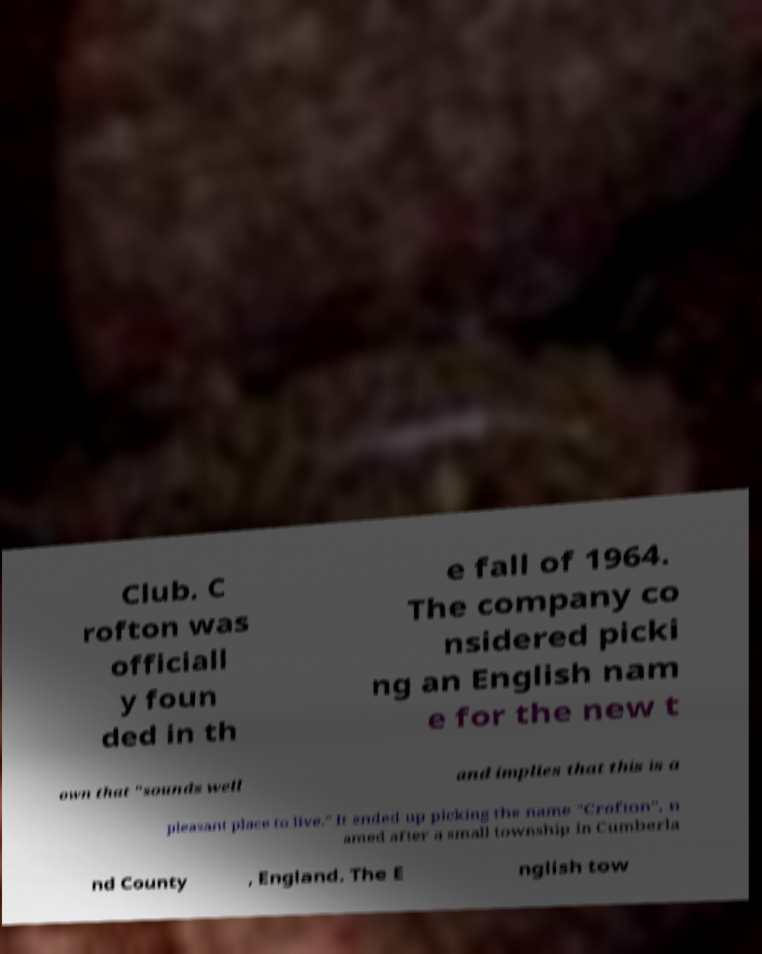Can you read and provide the text displayed in the image?This photo seems to have some interesting text. Can you extract and type it out for me? Club. C rofton was officiall y foun ded in th e fall of 1964. The company co nsidered picki ng an English nam e for the new t own that "sounds well and implies that this is a pleasant place to live." It ended up picking the name "Crofton", n amed after a small township in Cumberla nd County , England. The E nglish tow 